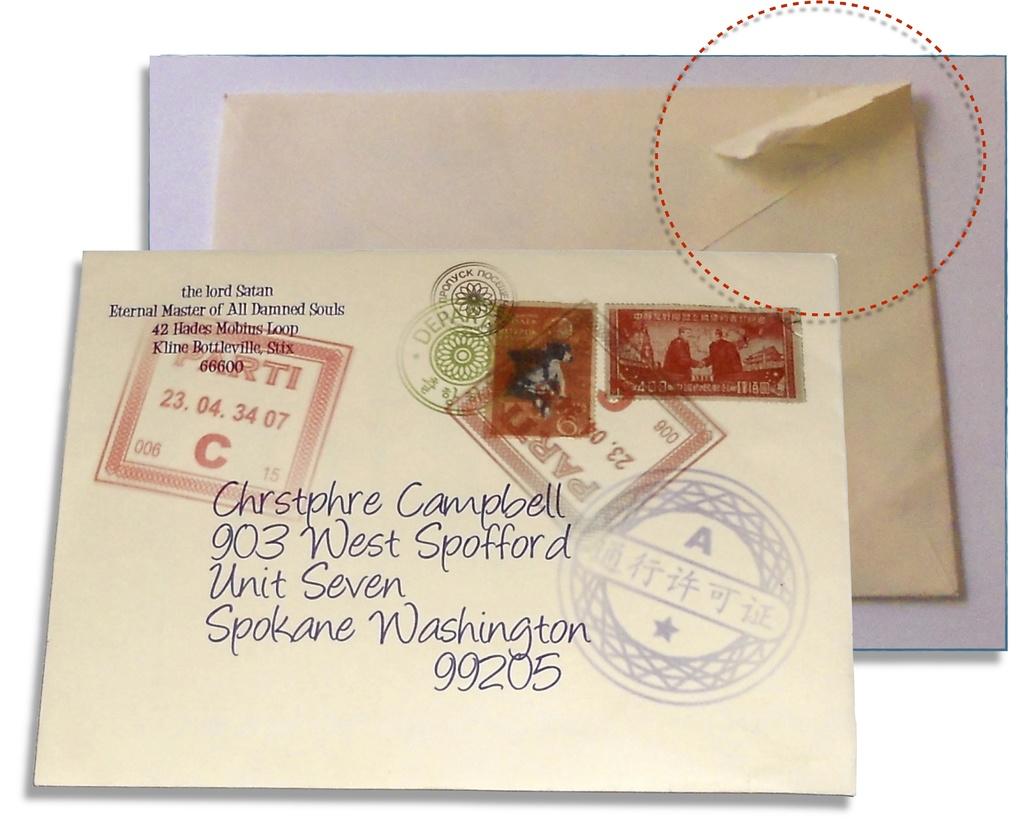What zip code is this being sent to?
Your answer should be very brief. 99205. What is the house number?
Offer a terse response. 903. 